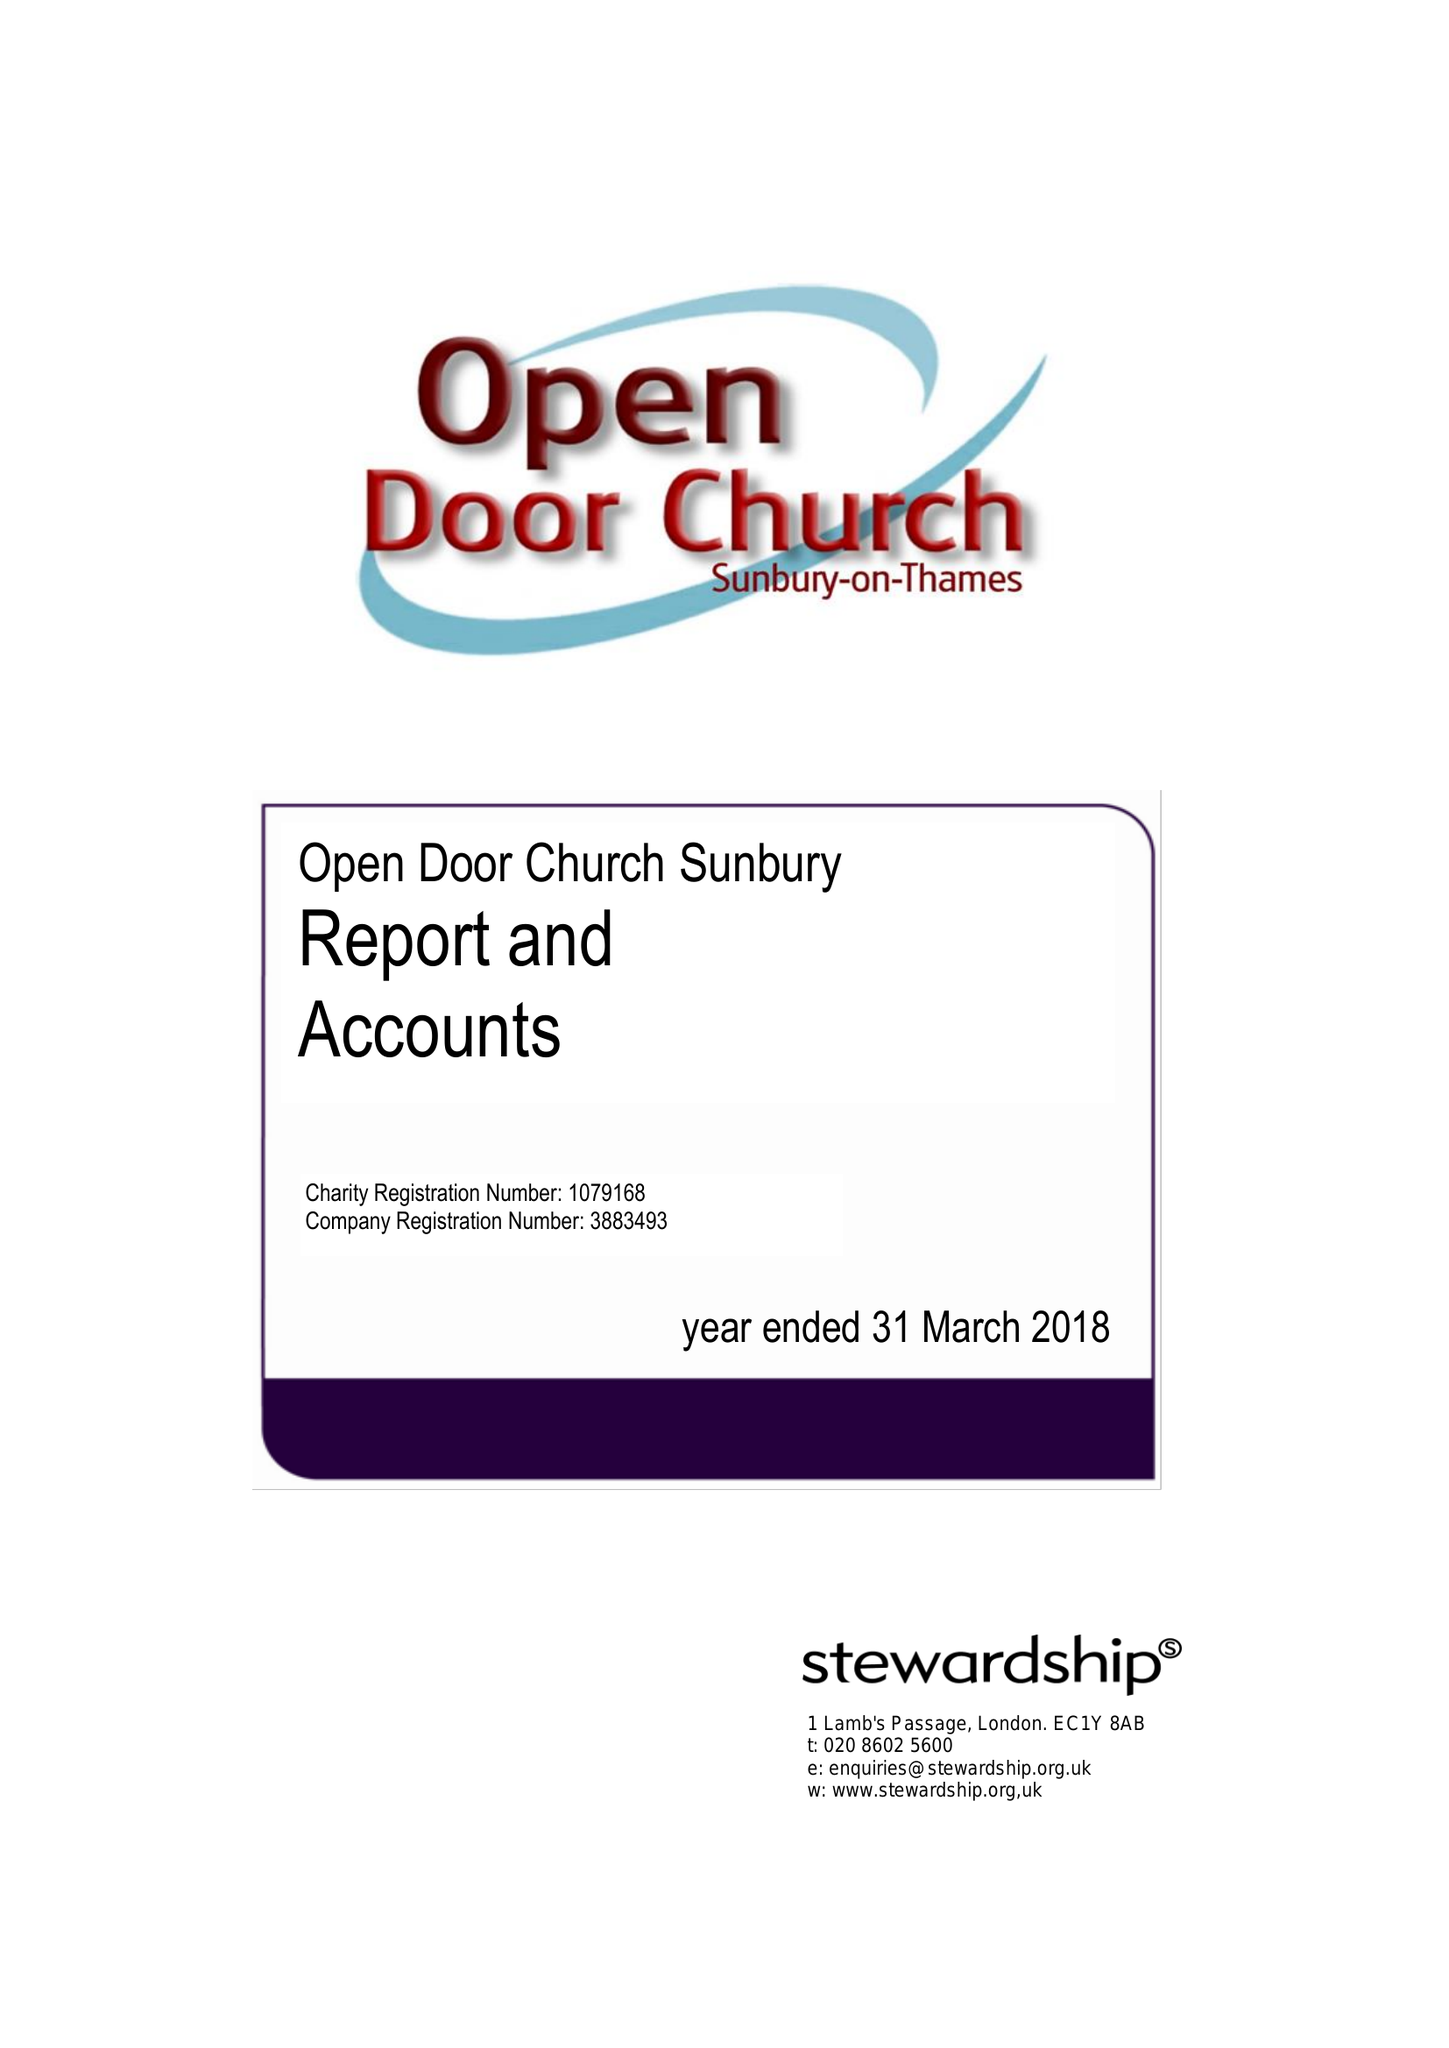What is the value for the address__postcode?
Answer the question using a single word or phrase. TW16 6QQ 